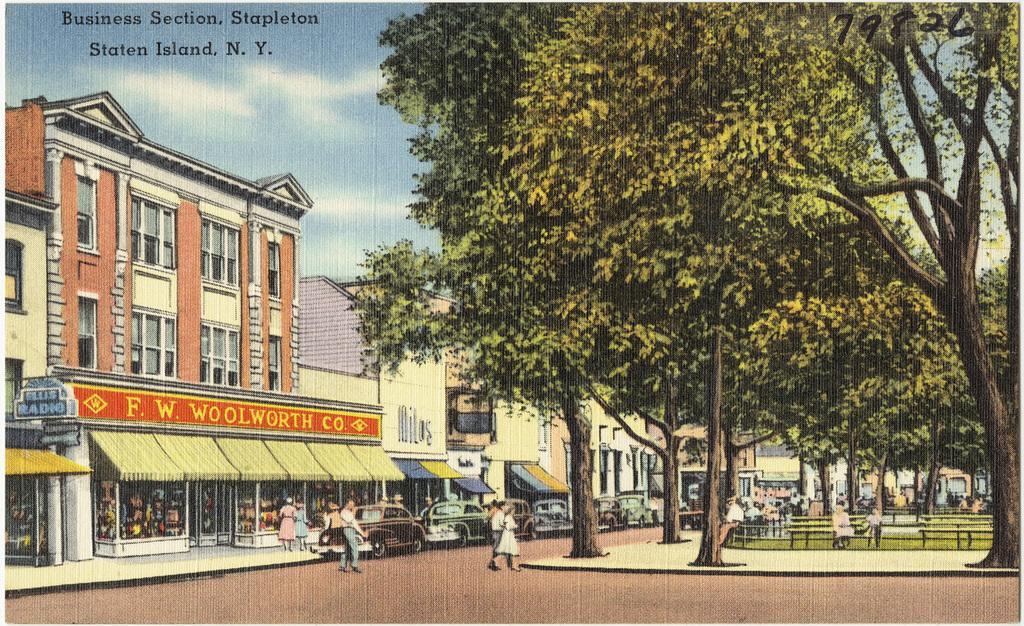Please provide a concise description of this image. This image is a painting. In this image there are buildings, trees, benches, people and cars. In the background there is sky and we can see text. 